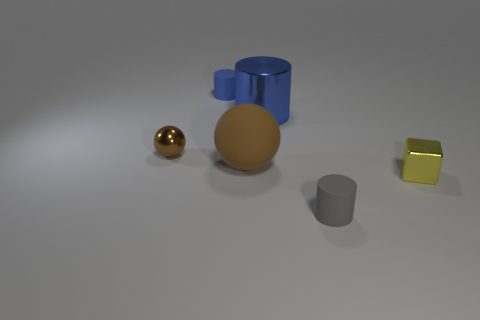How many other objects are the same color as the small sphere?
Offer a very short reply. 1. Is there another small metal object of the same shape as the yellow thing?
Provide a short and direct response. No. Is there any other thing that is the same shape as the small brown object?
Ensure brevity in your answer.  Yes. The small cylinder that is right of the matte cylinder behind the big blue object behind the yellow shiny block is made of what material?
Make the answer very short. Rubber. Is there a shiny block that has the same size as the rubber sphere?
Your answer should be compact. No. What color is the tiny matte thing that is on the right side of the matte cylinder behind the tiny gray matte thing?
Your answer should be very brief. Gray. How many small blue rubber objects are there?
Offer a very short reply. 1. Does the metal cube have the same color as the small sphere?
Provide a succinct answer. No. Is the number of small blue matte cylinders to the left of the blue rubber thing less than the number of small yellow shiny objects that are to the right of the yellow shiny thing?
Provide a succinct answer. No. What is the color of the small block?
Ensure brevity in your answer.  Yellow. 